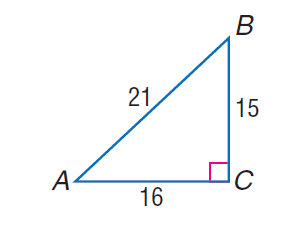Answer the mathemtical geometry problem and directly provide the correct option letter.
Question: find \sin A.
Choices: A: \frac { 5 } { 7 } B: \frac { 16 } { 21 } C: \frac { 15 } { 16 } D: \frac { 16 } { 15 } A 